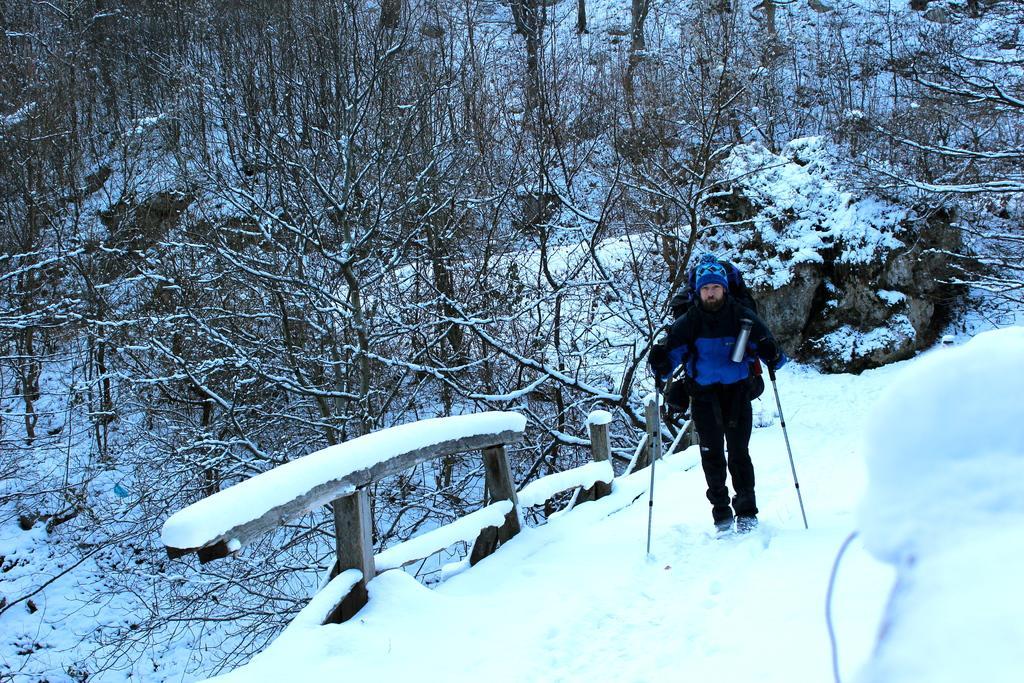What is the person in the image standing on? The person is standing on the snow. What is the person wearing in the image? The person is wearing a blue and black color dress. What is the person holding in the image? The person is holding sticks. What can be seen in the background of the image? There are trees in the background of the image. How many houses are visible in the image? There are no houses visible in the image; it features a person standing on snow with trees in the background. Is there a balloon tied to the person in the image? There is no balloon present in the image. 